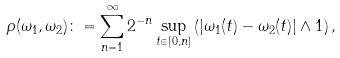Convert formula to latex. <formula><loc_0><loc_0><loc_500><loc_500>\rho ( \omega _ { 1 } , \omega _ { 2 } ) \colon = \sum _ { n = 1 } ^ { \infty } 2 ^ { - n } \sup _ { t \in [ 0 , n ] } \left ( | \omega _ { 1 } ( t ) - \omega _ { 2 } ( t ) | \wedge 1 \right ) ,</formula> 